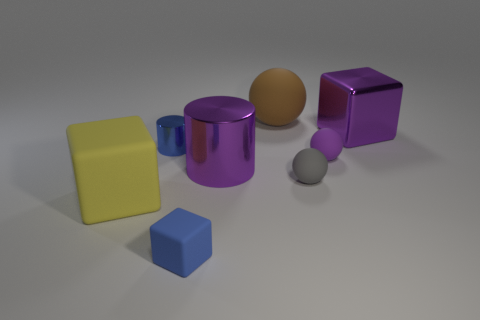What is the shape of the metallic thing that is the same color as the large shiny cylinder?
Provide a short and direct response. Cube. What color is the rubber sphere that is behind the big purple cylinder and right of the large brown rubber object?
Give a very brief answer. Purple. Are there more purple cubes to the right of the yellow cube than large green matte cylinders?
Make the answer very short. Yes. Is there a large matte block?
Offer a terse response. Yes. Is the tiny metal object the same color as the tiny block?
Make the answer very short. Yes. What number of large things are either brown rubber spheres or yellow cylinders?
Your answer should be very brief. 1. Are there any other things of the same color as the large cylinder?
Make the answer very short. Yes. There is a brown thing that is the same material as the small purple thing; what is its shape?
Your response must be concise. Sphere. There is a purple thing that is to the left of the tiny gray matte thing; what size is it?
Provide a short and direct response. Large. What is the shape of the small blue matte thing?
Provide a short and direct response. Cube. 